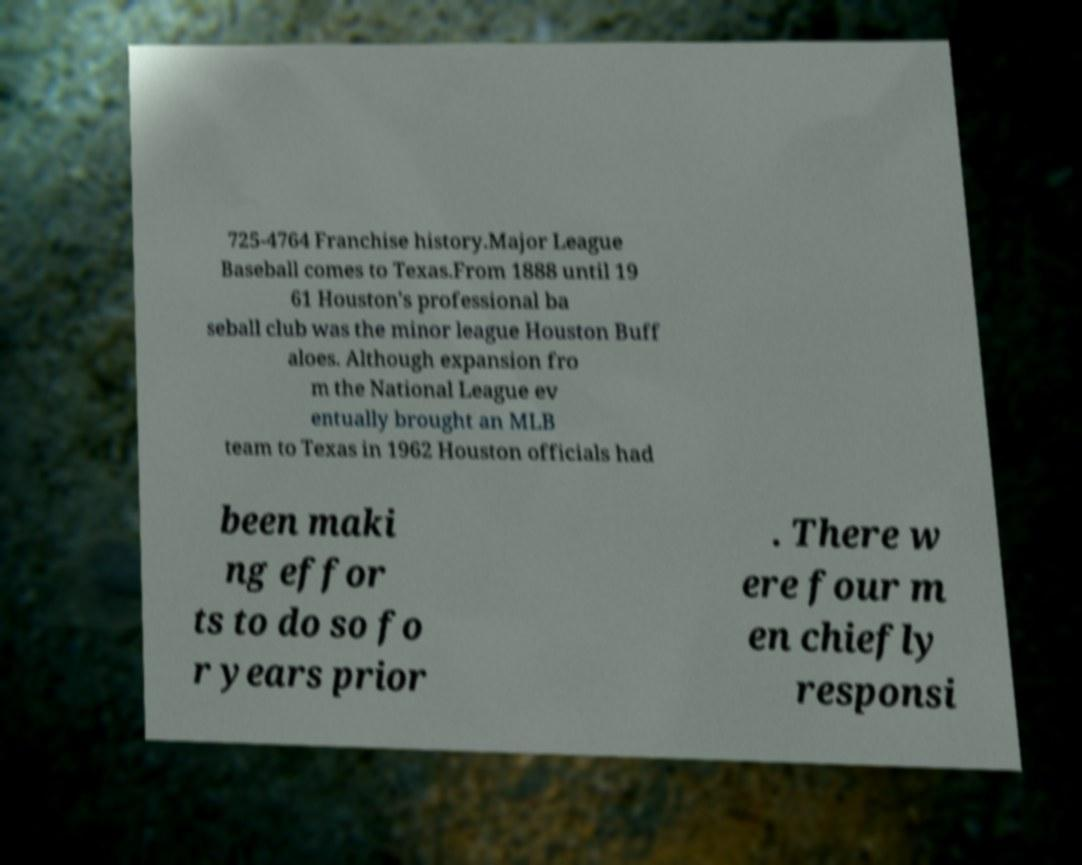Can you accurately transcribe the text from the provided image for me? 725-4764 Franchise history.Major League Baseball comes to Texas.From 1888 until 19 61 Houston's professional ba seball club was the minor league Houston Buff aloes. Although expansion fro m the National League ev entually brought an MLB team to Texas in 1962 Houston officials had been maki ng effor ts to do so fo r years prior . There w ere four m en chiefly responsi 